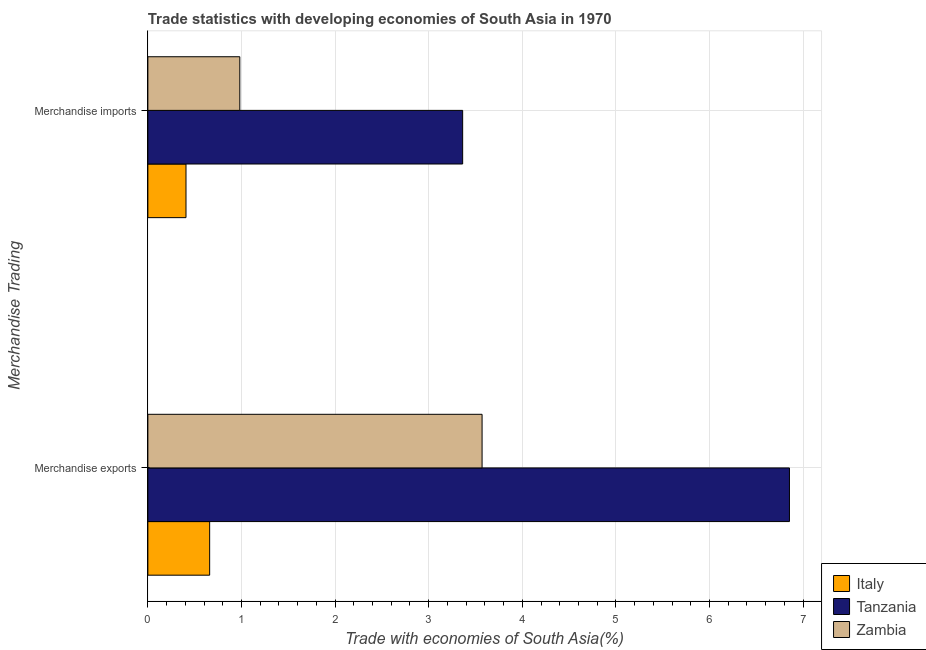How many different coloured bars are there?
Your response must be concise. 3. How many bars are there on the 1st tick from the top?
Offer a very short reply. 3. How many bars are there on the 1st tick from the bottom?
Your response must be concise. 3. What is the label of the 2nd group of bars from the top?
Your response must be concise. Merchandise exports. What is the merchandise imports in Zambia?
Provide a succinct answer. 0.98. Across all countries, what is the maximum merchandise exports?
Make the answer very short. 6.85. Across all countries, what is the minimum merchandise imports?
Offer a terse response. 0.41. In which country was the merchandise exports maximum?
Provide a short and direct response. Tanzania. What is the total merchandise imports in the graph?
Make the answer very short. 4.75. What is the difference between the merchandise exports in Italy and that in Tanzania?
Offer a very short reply. -6.19. What is the difference between the merchandise imports in Tanzania and the merchandise exports in Italy?
Ensure brevity in your answer.  2.7. What is the average merchandise exports per country?
Keep it short and to the point. 3.69. What is the difference between the merchandise imports and merchandise exports in Zambia?
Provide a succinct answer. -2.59. In how many countries, is the merchandise exports greater than 2.2 %?
Offer a terse response. 2. What is the ratio of the merchandise exports in Zambia to that in Tanzania?
Your answer should be very brief. 0.52. What does the 3rd bar from the top in Merchandise imports represents?
Provide a short and direct response. Italy. What does the 3rd bar from the bottom in Merchandise exports represents?
Give a very brief answer. Zambia. How many bars are there?
Your response must be concise. 6. What is the difference between two consecutive major ticks on the X-axis?
Make the answer very short. 1. Does the graph contain any zero values?
Keep it short and to the point. No. Does the graph contain grids?
Keep it short and to the point. Yes. Where does the legend appear in the graph?
Offer a very short reply. Bottom right. What is the title of the graph?
Provide a short and direct response. Trade statistics with developing economies of South Asia in 1970. Does "Marshall Islands" appear as one of the legend labels in the graph?
Your answer should be compact. No. What is the label or title of the X-axis?
Offer a terse response. Trade with economies of South Asia(%). What is the label or title of the Y-axis?
Offer a very short reply. Merchandise Trading. What is the Trade with economies of South Asia(%) in Italy in Merchandise exports?
Your answer should be very brief. 0.66. What is the Trade with economies of South Asia(%) in Tanzania in Merchandise exports?
Offer a terse response. 6.85. What is the Trade with economies of South Asia(%) of Zambia in Merchandise exports?
Provide a succinct answer. 3.57. What is the Trade with economies of South Asia(%) in Italy in Merchandise imports?
Provide a short and direct response. 0.41. What is the Trade with economies of South Asia(%) of Tanzania in Merchandise imports?
Ensure brevity in your answer.  3.36. What is the Trade with economies of South Asia(%) of Zambia in Merchandise imports?
Ensure brevity in your answer.  0.98. Across all Merchandise Trading, what is the maximum Trade with economies of South Asia(%) of Italy?
Ensure brevity in your answer.  0.66. Across all Merchandise Trading, what is the maximum Trade with economies of South Asia(%) of Tanzania?
Provide a succinct answer. 6.85. Across all Merchandise Trading, what is the maximum Trade with economies of South Asia(%) of Zambia?
Offer a terse response. 3.57. Across all Merchandise Trading, what is the minimum Trade with economies of South Asia(%) in Italy?
Ensure brevity in your answer.  0.41. Across all Merchandise Trading, what is the minimum Trade with economies of South Asia(%) in Tanzania?
Offer a terse response. 3.36. Across all Merchandise Trading, what is the minimum Trade with economies of South Asia(%) in Zambia?
Give a very brief answer. 0.98. What is the total Trade with economies of South Asia(%) in Italy in the graph?
Your response must be concise. 1.07. What is the total Trade with economies of South Asia(%) in Tanzania in the graph?
Your answer should be very brief. 10.22. What is the total Trade with economies of South Asia(%) of Zambia in the graph?
Give a very brief answer. 4.55. What is the difference between the Trade with economies of South Asia(%) in Italy in Merchandise exports and that in Merchandise imports?
Offer a very short reply. 0.25. What is the difference between the Trade with economies of South Asia(%) of Tanzania in Merchandise exports and that in Merchandise imports?
Give a very brief answer. 3.49. What is the difference between the Trade with economies of South Asia(%) of Zambia in Merchandise exports and that in Merchandise imports?
Offer a terse response. 2.59. What is the difference between the Trade with economies of South Asia(%) in Italy in Merchandise exports and the Trade with economies of South Asia(%) in Tanzania in Merchandise imports?
Offer a very short reply. -2.7. What is the difference between the Trade with economies of South Asia(%) in Italy in Merchandise exports and the Trade with economies of South Asia(%) in Zambia in Merchandise imports?
Offer a terse response. -0.32. What is the difference between the Trade with economies of South Asia(%) of Tanzania in Merchandise exports and the Trade with economies of South Asia(%) of Zambia in Merchandise imports?
Your answer should be very brief. 5.87. What is the average Trade with economies of South Asia(%) of Italy per Merchandise Trading?
Offer a terse response. 0.53. What is the average Trade with economies of South Asia(%) of Tanzania per Merchandise Trading?
Your answer should be compact. 5.11. What is the average Trade with economies of South Asia(%) of Zambia per Merchandise Trading?
Offer a terse response. 2.28. What is the difference between the Trade with economies of South Asia(%) of Italy and Trade with economies of South Asia(%) of Tanzania in Merchandise exports?
Your answer should be compact. -6.19. What is the difference between the Trade with economies of South Asia(%) in Italy and Trade with economies of South Asia(%) in Zambia in Merchandise exports?
Offer a very short reply. -2.91. What is the difference between the Trade with economies of South Asia(%) of Tanzania and Trade with economies of South Asia(%) of Zambia in Merchandise exports?
Provide a succinct answer. 3.28. What is the difference between the Trade with economies of South Asia(%) of Italy and Trade with economies of South Asia(%) of Tanzania in Merchandise imports?
Offer a very short reply. -2.96. What is the difference between the Trade with economies of South Asia(%) of Italy and Trade with economies of South Asia(%) of Zambia in Merchandise imports?
Provide a short and direct response. -0.57. What is the difference between the Trade with economies of South Asia(%) of Tanzania and Trade with economies of South Asia(%) of Zambia in Merchandise imports?
Your answer should be compact. 2.38. What is the ratio of the Trade with economies of South Asia(%) of Italy in Merchandise exports to that in Merchandise imports?
Make the answer very short. 1.62. What is the ratio of the Trade with economies of South Asia(%) in Tanzania in Merchandise exports to that in Merchandise imports?
Your answer should be compact. 2.04. What is the ratio of the Trade with economies of South Asia(%) of Zambia in Merchandise exports to that in Merchandise imports?
Your response must be concise. 3.63. What is the difference between the highest and the second highest Trade with economies of South Asia(%) of Italy?
Provide a succinct answer. 0.25. What is the difference between the highest and the second highest Trade with economies of South Asia(%) in Tanzania?
Your answer should be very brief. 3.49. What is the difference between the highest and the second highest Trade with economies of South Asia(%) of Zambia?
Your answer should be compact. 2.59. What is the difference between the highest and the lowest Trade with economies of South Asia(%) in Italy?
Ensure brevity in your answer.  0.25. What is the difference between the highest and the lowest Trade with economies of South Asia(%) of Tanzania?
Ensure brevity in your answer.  3.49. What is the difference between the highest and the lowest Trade with economies of South Asia(%) in Zambia?
Your response must be concise. 2.59. 